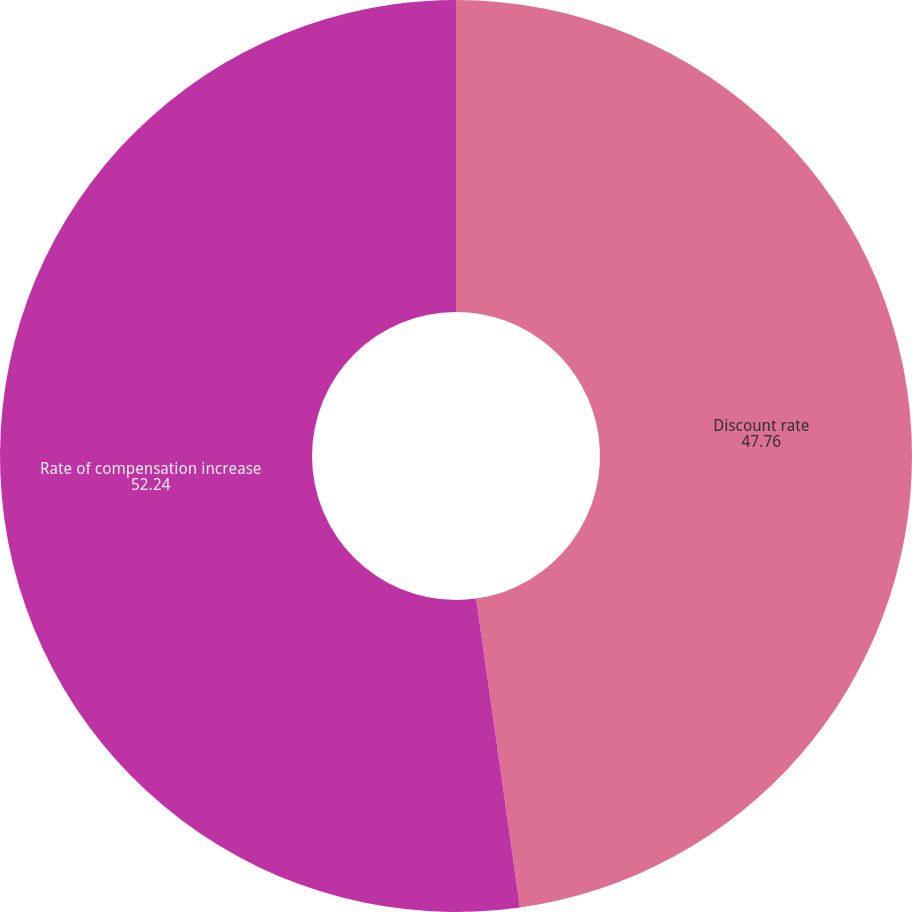Convert chart. <chart><loc_0><loc_0><loc_500><loc_500><pie_chart><fcel>Discount rate<fcel>Rate of compensation increase<nl><fcel>47.76%<fcel>52.24%<nl></chart> 